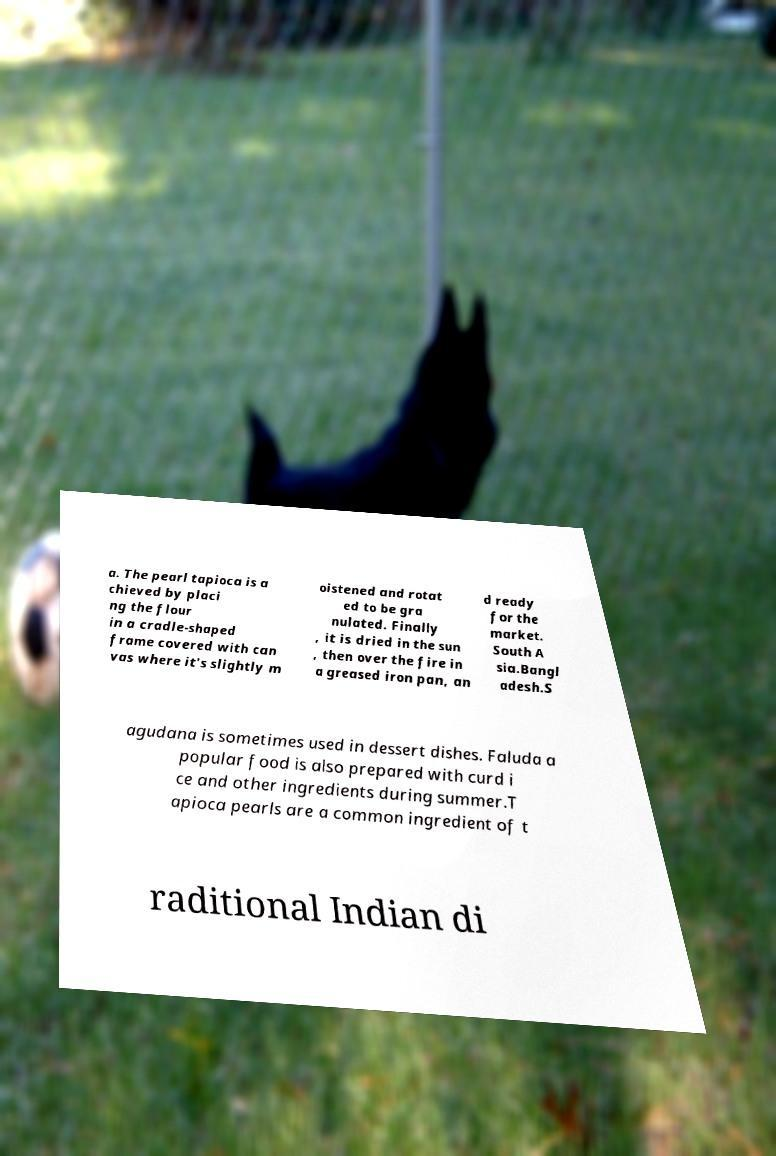I need the written content from this picture converted into text. Can you do that? a. The pearl tapioca is a chieved by placi ng the flour in a cradle-shaped frame covered with can vas where it's slightly m oistened and rotat ed to be gra nulated. Finally , it is dried in the sun , then over the fire in a greased iron pan, an d ready for the market. South A sia.Bangl adesh.S agudana is sometimes used in dessert dishes. Faluda a popular food is also prepared with curd i ce and other ingredients during summer.T apioca pearls are a common ingredient of t raditional Indian di 